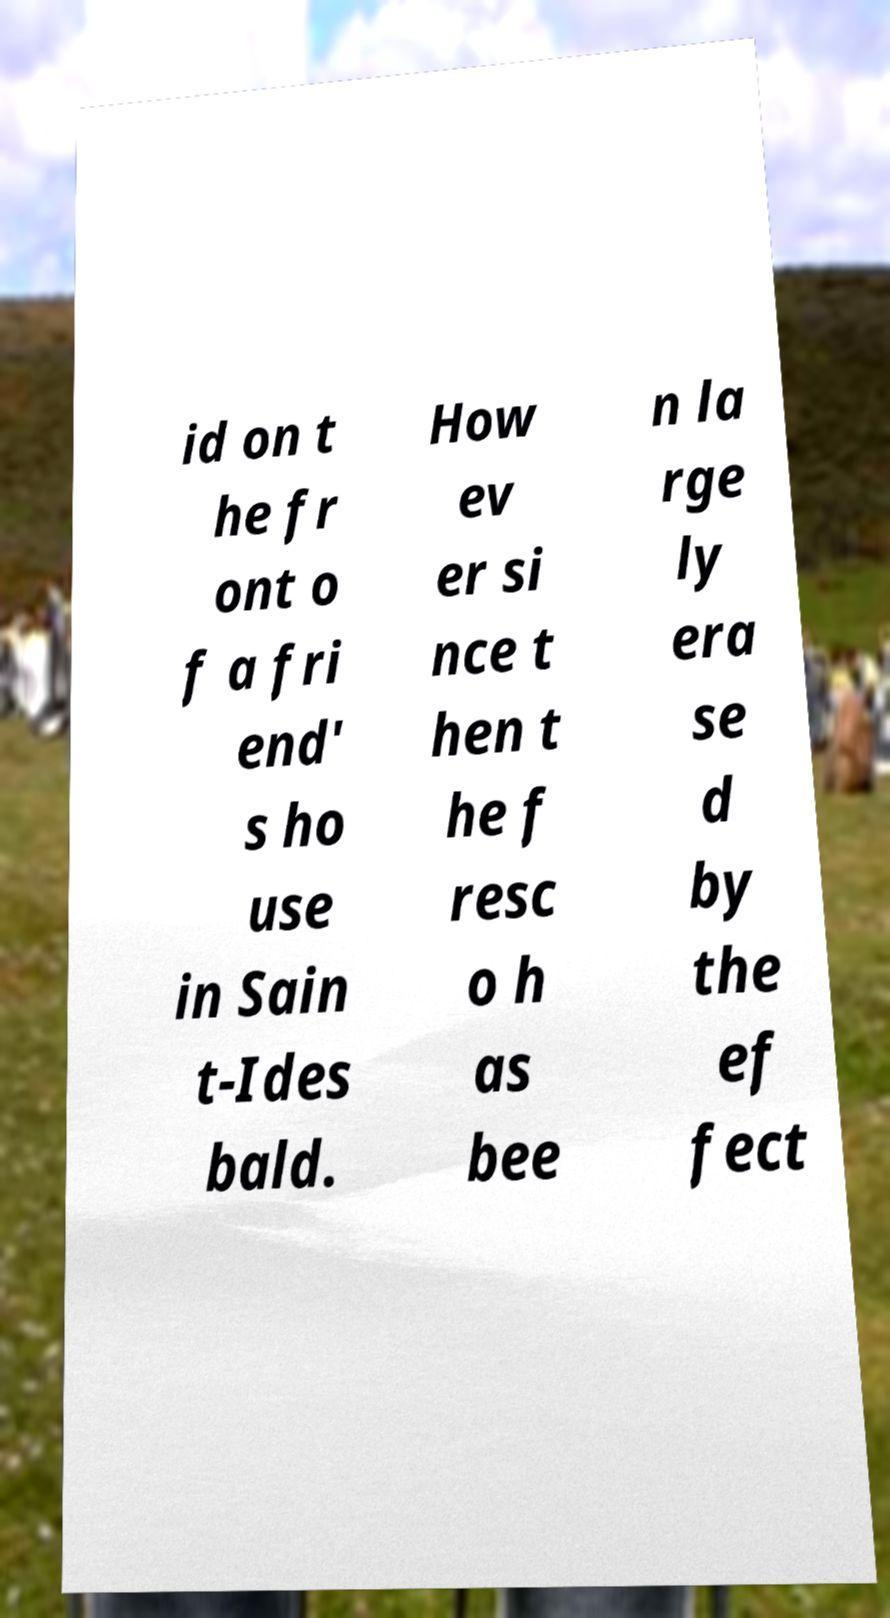What messages or text are displayed in this image? I need them in a readable, typed format. id on t he fr ont o f a fri end' s ho use in Sain t-Ides bald. How ev er si nce t hen t he f resc o h as bee n la rge ly era se d by the ef fect 